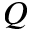<formula> <loc_0><loc_0><loc_500><loc_500>Q</formula> 